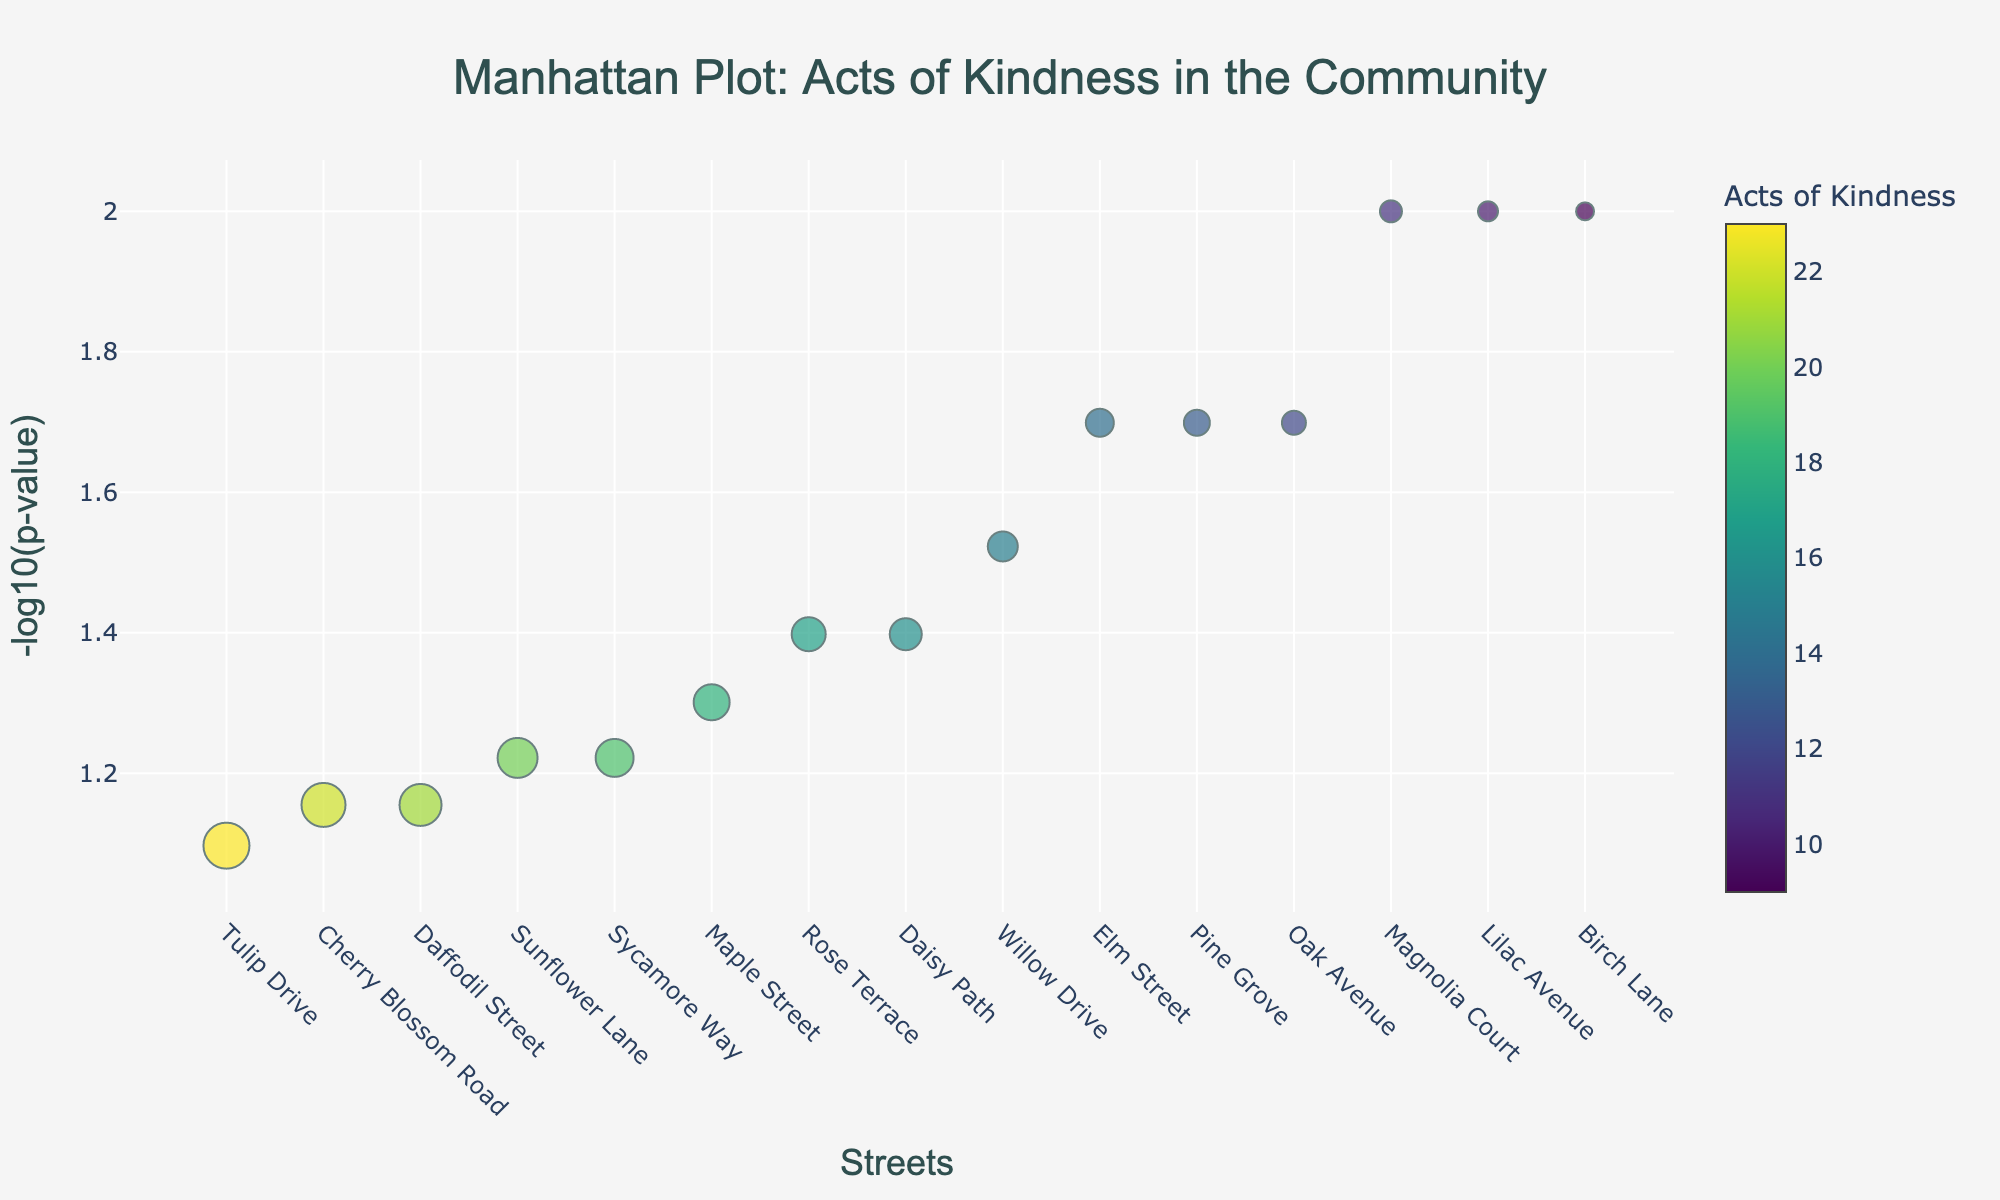What is the title of the plot? The title of the plot is positioned at the top center. It reads "Manhattan Plot: Acts of Kindness in the Community".
Answer: "Manhattan Plot: Acts of Kindness in the Community" How many streets have data plotted in the figure? By counting the data points on the x-axis, which represent different streets, we can see there are 15 streets listed.
Answer: 15 Which street observed the most acts of kindness? The street with the highest number of acts of kindness can be identified by the largest sized markers on the plot. By checking the hover text or sorting order of the data, it is "Tulip Drive" with 23 acts.
Answer: Tulip Drive Which street corresponds to the highest significance value? The highest significance value corresponds to the smallest negative log p-value, seen on the y-axis. Birch Lane, Magnolia Court, and Lilac Avenue all have significance values of 0.01, yielding the highest negative log p of 2.
Answer: Birch Lane, Magnolia Court, Lilac Avenue What's the median number of acts of kindness observed? To find the median, we need to sort the acts of kindness in ascending order and locate the middle value. The sorted order: [9, 10, 11, 12, 13, 14, 15, 16, 17, 18, 19, 20, 21, 22, 23]. The median is the 8th value, 16.
Answer: 16 Which street has the lowest negative log p-value? The lowest negative log p-value can be identified from the markers at the lowest point on the y-axis, which signifies the highest p-value. Cherry Blossom Road and Daffodil Street have the lowest negative log p-value of approximately 1.154.
Answer: Cherry Blossom Road, Daffodil Street Which street has more acts of kindness, Elm Street or Pine Grove? By comparing the sizes of the markers or reading the hover texts for Elm Street and Pine Grove, Elm Street had 14 acts of kindness, and Pine Grove had 13 acts of kindness.
Answer: Elm Street What is the significance value for Maple Street? By looking at the hover text for Maple Street, which indicates the significance value directly, we see Maple Street has a significance value of 0.05.
Answer: 0.05 Compare the negative log p-values for Oak Avenue and Willow Drive. Which one is higher? Checking the position on the y-axis, Oak Avenue's negative log p-value is higher (approximately 1.70) than Willow Drive's (about 1.52).
Answer: Oak Avenue Which street observed 18 acts of kindness, and what is its negative log p-value? From the hover text, it shows that Maple Street observed 18 acts of kindness with a negative log p-value of 1.30.
Answer: Maple Street, 1.30 